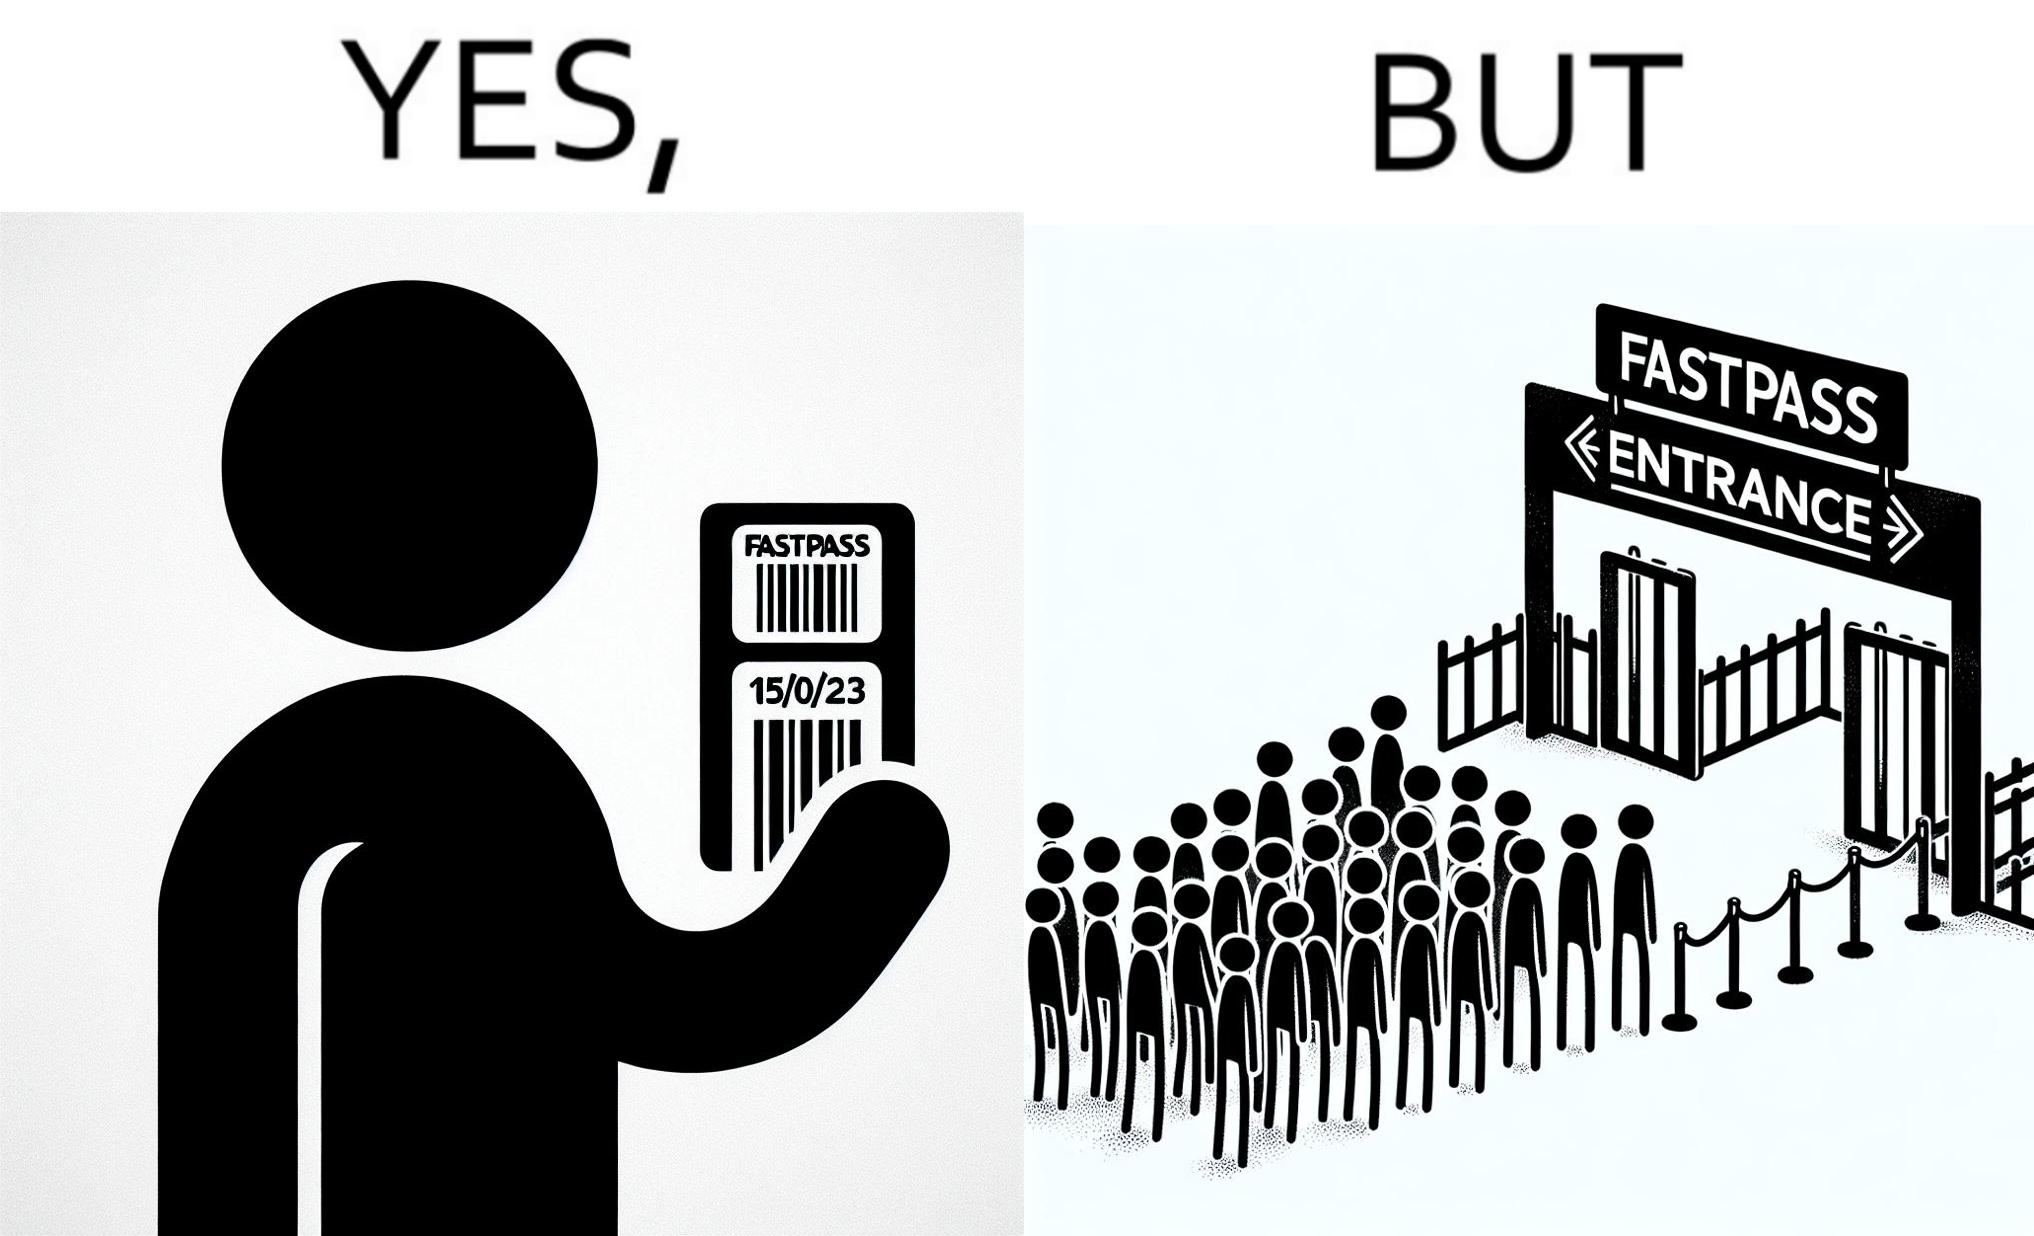Does this image contain satire or humor? Yes, this image is satirical. 